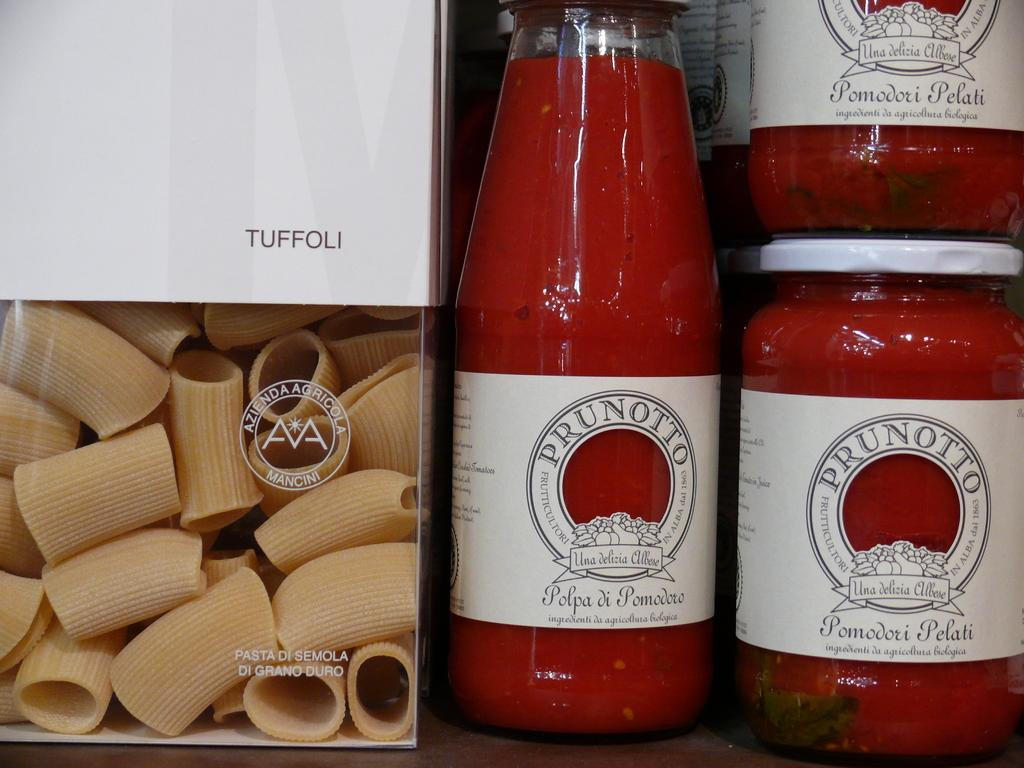What object in the image contains liquid? There is a bottle in the image, and it contains liquid. What else can be seen in the image besides the bottle? There are food items in the image. What type of rock is visible in the image? There is no rock present in the image. How many stockings are hanging in the image? There is no mention of stockings in the image. 